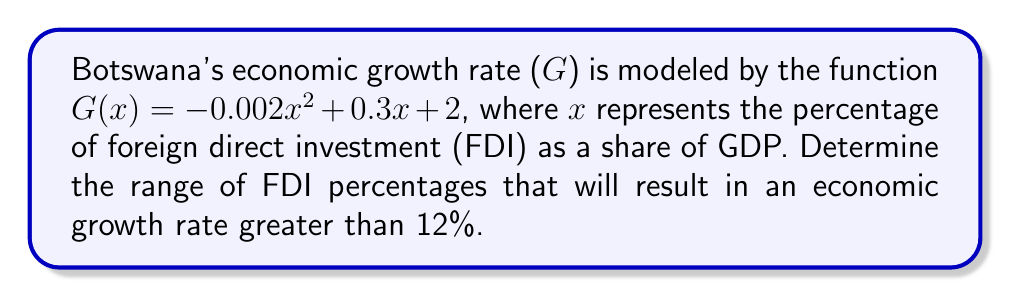Help me with this question. 1) We need to solve the inequality:
   $G(x) > 12$
   $-0.002x^2 + 0.3x + 2 > 12$

2) Rearrange the inequality:
   $-0.002x^2 + 0.3x - 10 > 0$

3) This is a quadratic inequality. To solve it, we first find the roots of the corresponding quadratic equation:
   $-0.002x^2 + 0.3x - 10 = 0$

4) Using the quadratic formula $x = \frac{-b \pm \sqrt{b^2 - 4ac}}{2a}$, where $a=-0.002$, $b=0.3$, and $c=-10$:

   $x = \frac{-0.3 \pm \sqrt{0.3^2 - 4(-0.002)(-10)}}{2(-0.002)}$

5) Simplifying:
   $x = \frac{-0.3 \pm \sqrt{0.09 - 0.08}}{-0.004} = \frac{-0.3 \pm \sqrt{0.01}}{-0.004} = \frac{-0.3 \pm 0.1}{-0.004}$

6) This gives us two roots:
   $x_1 = \frac{-0.3 + 0.1}{-0.004} = 50$
   $x_2 = \frac{-0.3 - 0.1}{-0.004} = 100$

7) Since the parabola opens downward (coefficient of $x^2$ is negative), the inequality $-0.002x^2 + 0.3x - 10 > 0$ is satisfied when x is between these two roots.

8) Therefore, the economic growth rate will be greater than 12% when the FDI percentage is between 50% and 100% of GDP.
Answer: $50\% < x < 100\%$ 